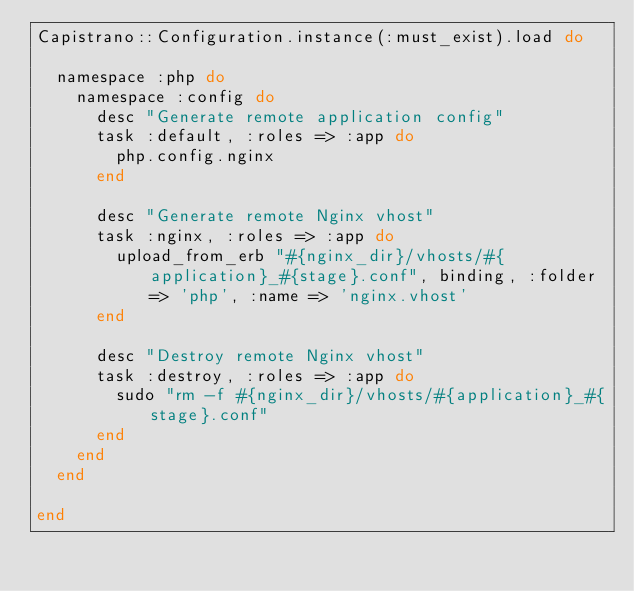Convert code to text. <code><loc_0><loc_0><loc_500><loc_500><_Ruby_>Capistrano::Configuration.instance(:must_exist).load do
  
  namespace :php do
    namespace :config do
      desc "Generate remote application config"
      task :default, :roles => :app do
        php.config.nginx
      end
      
      desc "Generate remote Nginx vhost"
      task :nginx, :roles => :app do
        upload_from_erb "#{nginx_dir}/vhosts/#{application}_#{stage}.conf", binding, :folder => 'php', :name => 'nginx.vhost'
      end
      
      desc "Destroy remote Nginx vhost"
      task :destroy, :roles => :app do
        sudo "rm -f #{nginx_dir}/vhosts/#{application}_#{stage}.conf"
      end
    end
  end
  
end</code> 